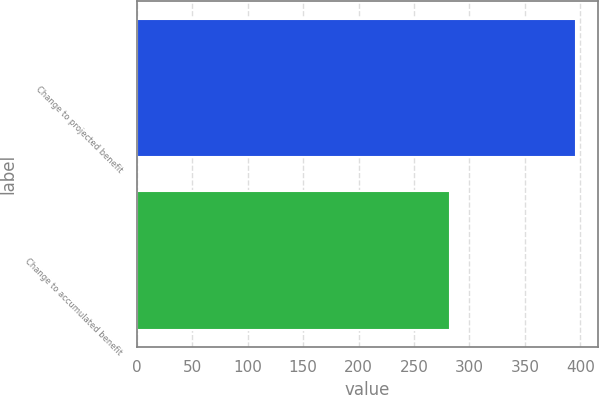Convert chart. <chart><loc_0><loc_0><loc_500><loc_500><bar_chart><fcel>Change to projected benefit<fcel>Change to accumulated benefit<nl><fcel>396<fcel>282<nl></chart> 